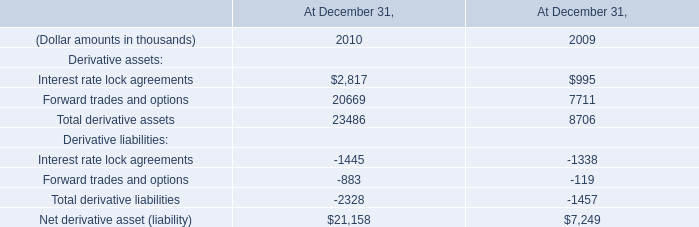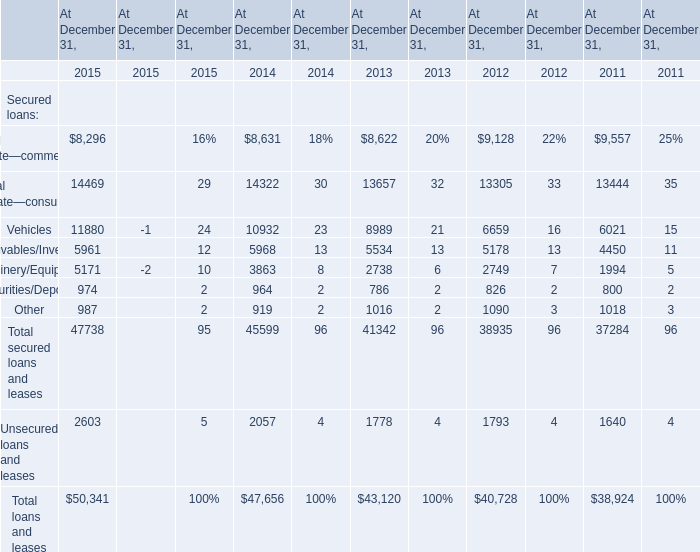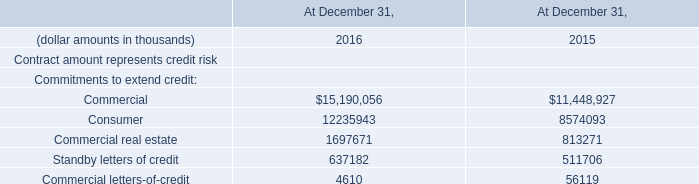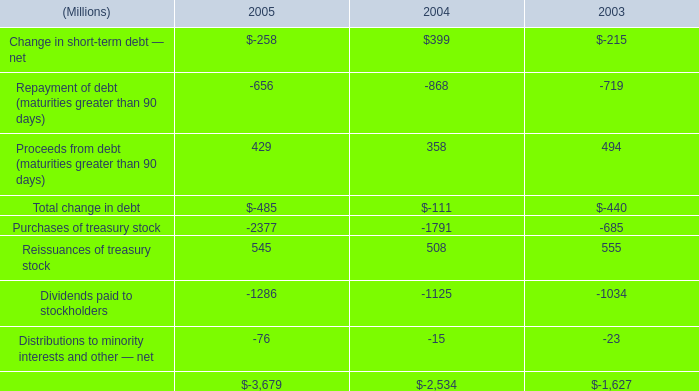what was the percentage change in the net cash used in financing activities from 2004 to 2005 
Computations: ((3679 - 2534) / 2534)
Answer: 0.45185. 